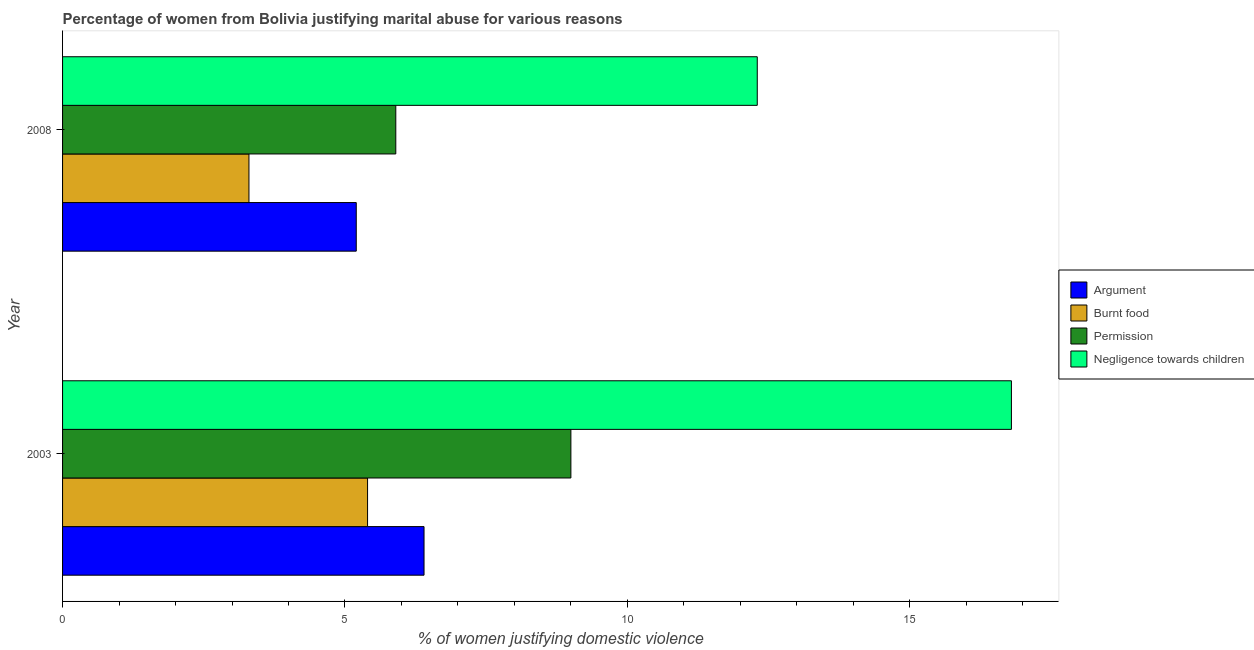Are the number of bars on each tick of the Y-axis equal?
Your response must be concise. Yes. How many bars are there on the 2nd tick from the top?
Provide a short and direct response. 4. How many bars are there on the 2nd tick from the bottom?
Your answer should be compact. 4. What is the label of the 2nd group of bars from the top?
Your response must be concise. 2003. Across all years, what is the maximum percentage of women justifying abuse for burning food?
Make the answer very short. 5.4. In which year was the percentage of women justifying abuse in the case of an argument maximum?
Keep it short and to the point. 2003. In which year was the percentage of women justifying abuse for showing negligence towards children minimum?
Keep it short and to the point. 2008. What is the total percentage of women justifying abuse in the case of an argument in the graph?
Your answer should be very brief. 11.6. What is the difference between the percentage of women justifying abuse for going without permission in 2003 and that in 2008?
Your answer should be very brief. 3.1. What is the average percentage of women justifying abuse for burning food per year?
Your answer should be very brief. 4.35. In the year 2003, what is the difference between the percentage of women justifying abuse in the case of an argument and percentage of women justifying abuse for showing negligence towards children?
Your response must be concise. -10.4. What is the ratio of the percentage of women justifying abuse in the case of an argument in 2003 to that in 2008?
Offer a terse response. 1.23. Is the difference between the percentage of women justifying abuse for going without permission in 2003 and 2008 greater than the difference between the percentage of women justifying abuse for showing negligence towards children in 2003 and 2008?
Your answer should be compact. No. Is it the case that in every year, the sum of the percentage of women justifying abuse in the case of an argument and percentage of women justifying abuse for burning food is greater than the sum of percentage of women justifying abuse for showing negligence towards children and percentage of women justifying abuse for going without permission?
Ensure brevity in your answer.  No. What does the 3rd bar from the top in 2003 represents?
Offer a terse response. Burnt food. What does the 1st bar from the bottom in 2003 represents?
Provide a short and direct response. Argument. Is it the case that in every year, the sum of the percentage of women justifying abuse in the case of an argument and percentage of women justifying abuse for burning food is greater than the percentage of women justifying abuse for going without permission?
Your answer should be very brief. Yes. How many bars are there?
Keep it short and to the point. 8. Are all the bars in the graph horizontal?
Offer a very short reply. Yes. How many years are there in the graph?
Make the answer very short. 2. What is the difference between two consecutive major ticks on the X-axis?
Provide a short and direct response. 5. Does the graph contain any zero values?
Give a very brief answer. No. How many legend labels are there?
Offer a very short reply. 4. How are the legend labels stacked?
Your answer should be very brief. Vertical. What is the title of the graph?
Your response must be concise. Percentage of women from Bolivia justifying marital abuse for various reasons. What is the label or title of the X-axis?
Offer a terse response. % of women justifying domestic violence. What is the % of women justifying domestic violence of Permission in 2003?
Keep it short and to the point. 9. Across all years, what is the maximum % of women justifying domestic violence of Permission?
Give a very brief answer. 9. Across all years, what is the maximum % of women justifying domestic violence of Negligence towards children?
Your answer should be very brief. 16.8. Across all years, what is the minimum % of women justifying domestic violence in Burnt food?
Ensure brevity in your answer.  3.3. What is the total % of women justifying domestic violence in Burnt food in the graph?
Your answer should be compact. 8.7. What is the total % of women justifying domestic violence in Negligence towards children in the graph?
Provide a short and direct response. 29.1. What is the difference between the % of women justifying domestic violence of Argument in 2003 and that in 2008?
Your answer should be compact. 1.2. What is the difference between the % of women justifying domestic violence in Burnt food in 2003 and that in 2008?
Provide a short and direct response. 2.1. What is the difference between the % of women justifying domestic violence in Permission in 2003 and that in 2008?
Keep it short and to the point. 3.1. What is the difference between the % of women justifying domestic violence of Argument in 2003 and the % of women justifying domestic violence of Permission in 2008?
Provide a succinct answer. 0.5. What is the difference between the % of women justifying domestic violence in Burnt food in 2003 and the % of women justifying domestic violence in Negligence towards children in 2008?
Offer a very short reply. -6.9. What is the difference between the % of women justifying domestic violence in Permission in 2003 and the % of women justifying domestic violence in Negligence towards children in 2008?
Provide a short and direct response. -3.3. What is the average % of women justifying domestic violence of Argument per year?
Your answer should be compact. 5.8. What is the average % of women justifying domestic violence of Burnt food per year?
Your response must be concise. 4.35. What is the average % of women justifying domestic violence in Permission per year?
Provide a short and direct response. 7.45. What is the average % of women justifying domestic violence in Negligence towards children per year?
Your answer should be compact. 14.55. In the year 2003, what is the difference between the % of women justifying domestic violence in Argument and % of women justifying domestic violence in Permission?
Your answer should be very brief. -2.6. In the year 2003, what is the difference between the % of women justifying domestic violence of Burnt food and % of women justifying domestic violence of Permission?
Give a very brief answer. -3.6. In the year 2003, what is the difference between the % of women justifying domestic violence of Permission and % of women justifying domestic violence of Negligence towards children?
Provide a short and direct response. -7.8. In the year 2008, what is the difference between the % of women justifying domestic violence of Argument and % of women justifying domestic violence of Burnt food?
Ensure brevity in your answer.  1.9. In the year 2008, what is the difference between the % of women justifying domestic violence in Burnt food and % of women justifying domestic violence in Negligence towards children?
Your response must be concise. -9. What is the ratio of the % of women justifying domestic violence of Argument in 2003 to that in 2008?
Provide a succinct answer. 1.23. What is the ratio of the % of women justifying domestic violence in Burnt food in 2003 to that in 2008?
Give a very brief answer. 1.64. What is the ratio of the % of women justifying domestic violence of Permission in 2003 to that in 2008?
Provide a succinct answer. 1.53. What is the ratio of the % of women justifying domestic violence of Negligence towards children in 2003 to that in 2008?
Ensure brevity in your answer.  1.37. What is the difference between the highest and the second highest % of women justifying domestic violence of Argument?
Ensure brevity in your answer.  1.2. What is the difference between the highest and the second highest % of women justifying domestic violence in Burnt food?
Provide a succinct answer. 2.1. What is the difference between the highest and the lowest % of women justifying domestic violence of Burnt food?
Make the answer very short. 2.1. What is the difference between the highest and the lowest % of women justifying domestic violence of Permission?
Offer a very short reply. 3.1. What is the difference between the highest and the lowest % of women justifying domestic violence in Negligence towards children?
Provide a short and direct response. 4.5. 